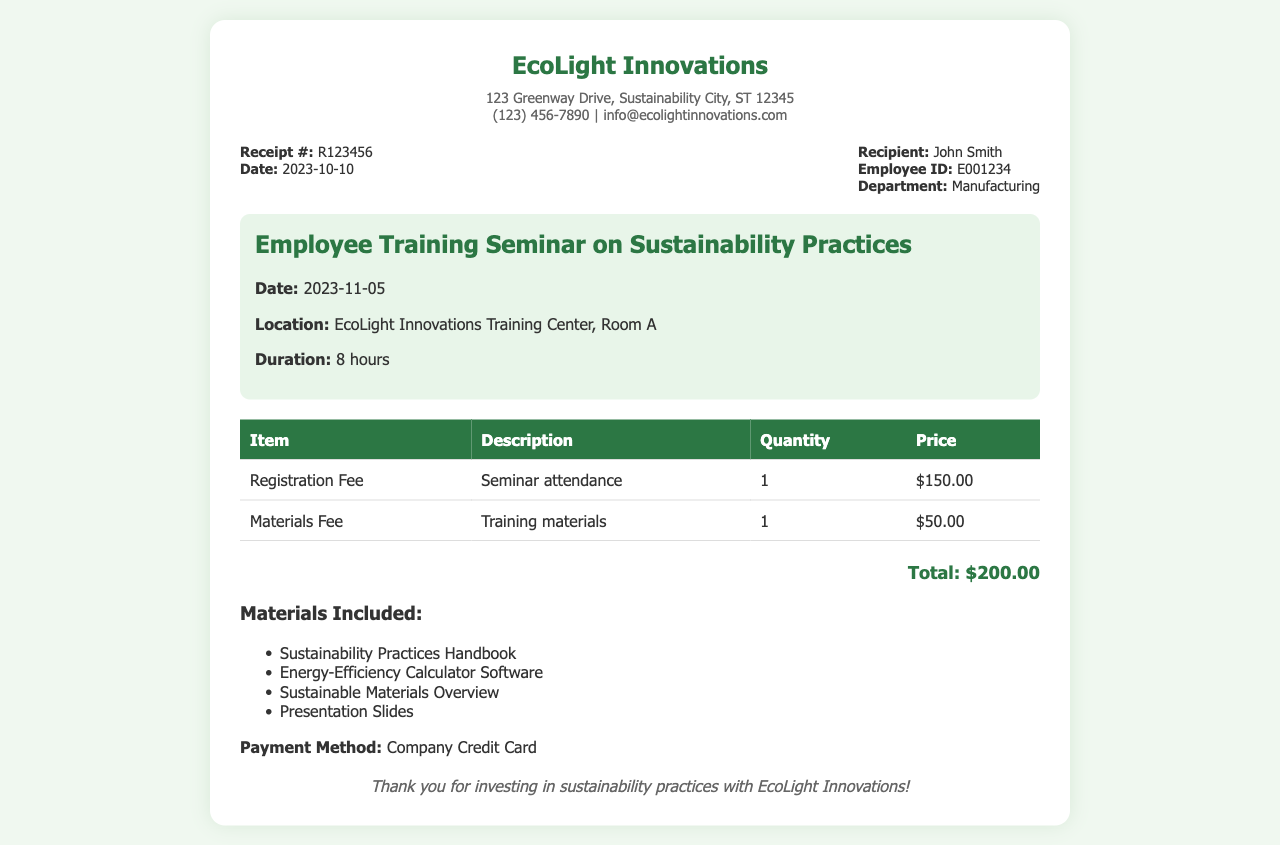What is the receipt number? The receipt number is found in the receipt details section, labeled as "Receipt #:".
Answer: R123456 What is the total amount due? The total amount can be found at the bottom of the receipt, labeled as "Total:".
Answer: $200.00 Who is the recipient of the receipt? The recipient's name is stated in the receipt details section under "Recipient:".
Answer: John Smith What is the date of the seminar? The seminar date is mentioned in the seminar info section under "Date:".
Answer: 2023-11-05 How many hours is the seminar? The duration of the seminar is listed in the seminar info section under "Duration:".
Answer: 8 hours What materials are included in the training? Included materials are listed in a separate section titled "Materials Included:".
Answer: Sustainability Practices Handbook, Energy-Efficiency Calculator Software, Sustainable Materials Overview, Presentation Slides What was the payment method? The payment method can be found in the last section of the document, labeled "Payment Method:".
Answer: Company Credit Card What department is John Smith in? John Smith's department is detailed in the receipt details section under "Department:".
Answer: Manufacturing What was the materials fee? The materials fee is specified in the table with a description under "Materials Fee".
Answer: $50.00 